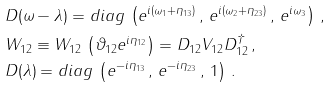<formula> <loc_0><loc_0><loc_500><loc_500>\null & \null D ( \omega - \lambda ) = d i a g \, \left ( e ^ { i ( \omega _ { 1 } + \eta _ { 1 3 } ) } \, , \, e ^ { i ( \omega _ { 2 } + \eta _ { 2 3 } ) } \, , \, e ^ { i \omega _ { 3 } } \right ) \, , \\ \null & \null W _ { 1 2 } \equiv W _ { 1 2 } \, \left ( \vartheta _ { 1 2 } e ^ { i \eta _ { 1 2 } } \right ) = D _ { 1 2 } V _ { 1 2 } D _ { 1 2 } ^ { \dagger } \, , \\ \null & \null D ( \lambda ) = d i a g \, \left ( e ^ { - i \eta _ { 1 3 } } \, , \, e ^ { - i \eta _ { 2 3 } } \, , \, 1 \right ) \, .</formula> 